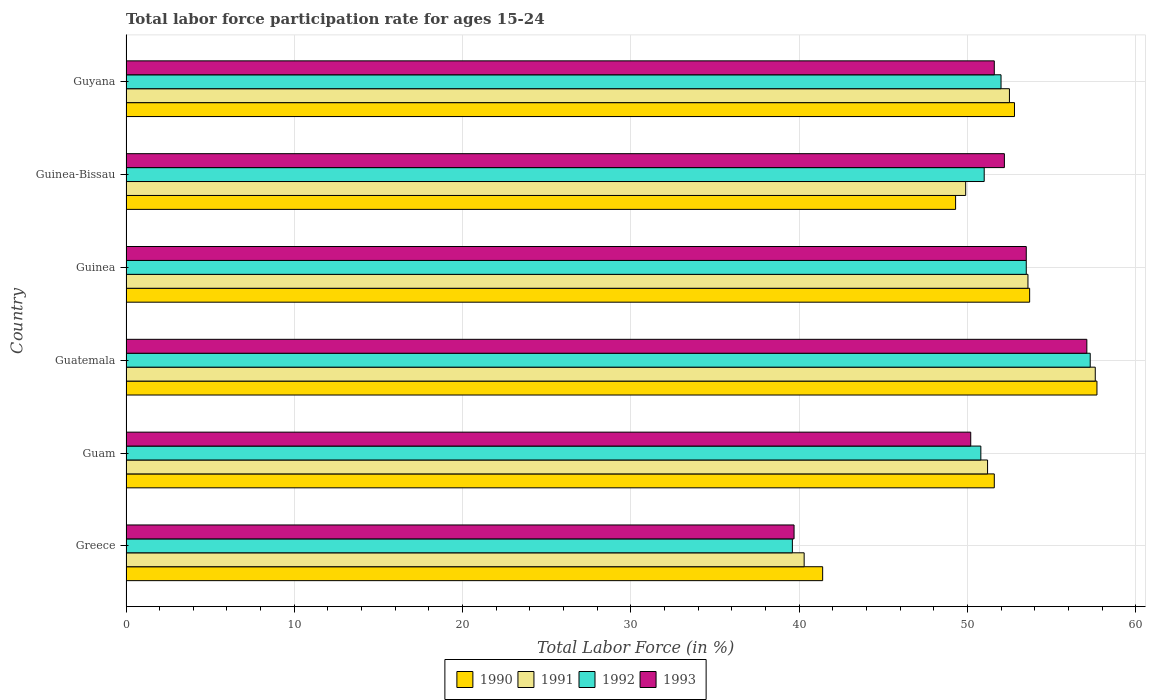Are the number of bars per tick equal to the number of legend labels?
Provide a succinct answer. Yes. What is the label of the 5th group of bars from the top?
Provide a short and direct response. Guam. In how many cases, is the number of bars for a given country not equal to the number of legend labels?
Give a very brief answer. 0. What is the labor force participation rate in 1990 in Guam?
Give a very brief answer. 51.6. Across all countries, what is the maximum labor force participation rate in 1993?
Provide a succinct answer. 57.1. Across all countries, what is the minimum labor force participation rate in 1993?
Give a very brief answer. 39.7. In which country was the labor force participation rate in 1991 maximum?
Provide a short and direct response. Guatemala. What is the total labor force participation rate in 1991 in the graph?
Offer a very short reply. 305.1. What is the difference between the labor force participation rate in 1993 in Guinea-Bissau and that in Guyana?
Provide a succinct answer. 0.6. What is the average labor force participation rate in 1993 per country?
Keep it short and to the point. 50.72. What is the difference between the labor force participation rate in 1993 and labor force participation rate in 1991 in Guatemala?
Ensure brevity in your answer.  -0.5. What is the ratio of the labor force participation rate in 1992 in Guinea to that in Guinea-Bissau?
Your answer should be compact. 1.05. Is the labor force participation rate in 1992 in Guatemala less than that in Guinea-Bissau?
Offer a terse response. No. What is the difference between the highest and the second highest labor force participation rate in 1990?
Keep it short and to the point. 4. What is the difference between the highest and the lowest labor force participation rate in 1992?
Provide a short and direct response. 17.7. Is the sum of the labor force participation rate in 1992 in Guam and Guyana greater than the maximum labor force participation rate in 1991 across all countries?
Give a very brief answer. Yes. What does the 1st bar from the top in Guyana represents?
Give a very brief answer. 1993. Is it the case that in every country, the sum of the labor force participation rate in 1991 and labor force participation rate in 1990 is greater than the labor force participation rate in 1992?
Keep it short and to the point. Yes. How many bars are there?
Keep it short and to the point. 24. How many countries are there in the graph?
Give a very brief answer. 6. What is the difference between two consecutive major ticks on the X-axis?
Ensure brevity in your answer.  10. Are the values on the major ticks of X-axis written in scientific E-notation?
Keep it short and to the point. No. Does the graph contain grids?
Provide a succinct answer. Yes. Where does the legend appear in the graph?
Give a very brief answer. Bottom center. What is the title of the graph?
Give a very brief answer. Total labor force participation rate for ages 15-24. Does "1966" appear as one of the legend labels in the graph?
Your answer should be very brief. No. What is the Total Labor Force (in %) in 1990 in Greece?
Give a very brief answer. 41.4. What is the Total Labor Force (in %) of 1991 in Greece?
Your answer should be compact. 40.3. What is the Total Labor Force (in %) in 1992 in Greece?
Your response must be concise. 39.6. What is the Total Labor Force (in %) in 1993 in Greece?
Your answer should be compact. 39.7. What is the Total Labor Force (in %) of 1990 in Guam?
Keep it short and to the point. 51.6. What is the Total Labor Force (in %) of 1991 in Guam?
Provide a succinct answer. 51.2. What is the Total Labor Force (in %) of 1992 in Guam?
Your answer should be compact. 50.8. What is the Total Labor Force (in %) in 1993 in Guam?
Ensure brevity in your answer.  50.2. What is the Total Labor Force (in %) of 1990 in Guatemala?
Ensure brevity in your answer.  57.7. What is the Total Labor Force (in %) in 1991 in Guatemala?
Make the answer very short. 57.6. What is the Total Labor Force (in %) of 1992 in Guatemala?
Make the answer very short. 57.3. What is the Total Labor Force (in %) in 1993 in Guatemala?
Offer a terse response. 57.1. What is the Total Labor Force (in %) of 1990 in Guinea?
Provide a succinct answer. 53.7. What is the Total Labor Force (in %) of 1991 in Guinea?
Offer a terse response. 53.6. What is the Total Labor Force (in %) of 1992 in Guinea?
Provide a succinct answer. 53.5. What is the Total Labor Force (in %) in 1993 in Guinea?
Provide a succinct answer. 53.5. What is the Total Labor Force (in %) in 1990 in Guinea-Bissau?
Your answer should be compact. 49.3. What is the Total Labor Force (in %) in 1991 in Guinea-Bissau?
Your answer should be compact. 49.9. What is the Total Labor Force (in %) in 1992 in Guinea-Bissau?
Your answer should be compact. 51. What is the Total Labor Force (in %) in 1993 in Guinea-Bissau?
Your answer should be very brief. 52.2. What is the Total Labor Force (in %) of 1990 in Guyana?
Make the answer very short. 52.8. What is the Total Labor Force (in %) in 1991 in Guyana?
Your answer should be very brief. 52.5. What is the Total Labor Force (in %) of 1992 in Guyana?
Offer a very short reply. 52. What is the Total Labor Force (in %) in 1993 in Guyana?
Give a very brief answer. 51.6. Across all countries, what is the maximum Total Labor Force (in %) in 1990?
Give a very brief answer. 57.7. Across all countries, what is the maximum Total Labor Force (in %) of 1991?
Offer a very short reply. 57.6. Across all countries, what is the maximum Total Labor Force (in %) in 1992?
Give a very brief answer. 57.3. Across all countries, what is the maximum Total Labor Force (in %) in 1993?
Provide a succinct answer. 57.1. Across all countries, what is the minimum Total Labor Force (in %) in 1990?
Ensure brevity in your answer.  41.4. Across all countries, what is the minimum Total Labor Force (in %) of 1991?
Offer a very short reply. 40.3. Across all countries, what is the minimum Total Labor Force (in %) of 1992?
Provide a short and direct response. 39.6. Across all countries, what is the minimum Total Labor Force (in %) in 1993?
Your response must be concise. 39.7. What is the total Total Labor Force (in %) of 1990 in the graph?
Give a very brief answer. 306.5. What is the total Total Labor Force (in %) in 1991 in the graph?
Your response must be concise. 305.1. What is the total Total Labor Force (in %) of 1992 in the graph?
Your answer should be compact. 304.2. What is the total Total Labor Force (in %) in 1993 in the graph?
Your response must be concise. 304.3. What is the difference between the Total Labor Force (in %) in 1991 in Greece and that in Guam?
Make the answer very short. -10.9. What is the difference between the Total Labor Force (in %) in 1992 in Greece and that in Guam?
Your response must be concise. -11.2. What is the difference between the Total Labor Force (in %) of 1990 in Greece and that in Guatemala?
Make the answer very short. -16.3. What is the difference between the Total Labor Force (in %) of 1991 in Greece and that in Guatemala?
Offer a very short reply. -17.3. What is the difference between the Total Labor Force (in %) of 1992 in Greece and that in Guatemala?
Your answer should be very brief. -17.7. What is the difference between the Total Labor Force (in %) in 1993 in Greece and that in Guatemala?
Your answer should be compact. -17.4. What is the difference between the Total Labor Force (in %) in 1990 in Greece and that in Guinea?
Your answer should be compact. -12.3. What is the difference between the Total Labor Force (in %) in 1991 in Greece and that in Guinea?
Keep it short and to the point. -13.3. What is the difference between the Total Labor Force (in %) in 1992 in Greece and that in Guinea?
Offer a terse response. -13.9. What is the difference between the Total Labor Force (in %) in 1991 in Greece and that in Guinea-Bissau?
Your answer should be very brief. -9.6. What is the difference between the Total Labor Force (in %) in 1992 in Greece and that in Guinea-Bissau?
Offer a very short reply. -11.4. What is the difference between the Total Labor Force (in %) in 1993 in Greece and that in Guinea-Bissau?
Make the answer very short. -12.5. What is the difference between the Total Labor Force (in %) in 1992 in Guam and that in Guatemala?
Provide a succinct answer. -6.5. What is the difference between the Total Labor Force (in %) of 1993 in Guam and that in Guatemala?
Your answer should be compact. -6.9. What is the difference between the Total Labor Force (in %) of 1990 in Guam and that in Guinea?
Your answer should be compact. -2.1. What is the difference between the Total Labor Force (in %) in 1991 in Guam and that in Guinea?
Your answer should be very brief. -2.4. What is the difference between the Total Labor Force (in %) of 1990 in Guam and that in Guinea-Bissau?
Your response must be concise. 2.3. What is the difference between the Total Labor Force (in %) in 1992 in Guam and that in Guinea-Bissau?
Offer a terse response. -0.2. What is the difference between the Total Labor Force (in %) in 1991 in Guatemala and that in Guinea?
Give a very brief answer. 4. What is the difference between the Total Labor Force (in %) in 1993 in Guatemala and that in Guinea?
Keep it short and to the point. 3.6. What is the difference between the Total Labor Force (in %) of 1990 in Guatemala and that in Guinea-Bissau?
Your answer should be very brief. 8.4. What is the difference between the Total Labor Force (in %) of 1993 in Guatemala and that in Guinea-Bissau?
Ensure brevity in your answer.  4.9. What is the difference between the Total Labor Force (in %) of 1990 in Guatemala and that in Guyana?
Provide a succinct answer. 4.9. What is the difference between the Total Labor Force (in %) of 1992 in Guatemala and that in Guyana?
Offer a very short reply. 5.3. What is the difference between the Total Labor Force (in %) in 1993 in Guatemala and that in Guyana?
Keep it short and to the point. 5.5. What is the difference between the Total Labor Force (in %) of 1990 in Guinea and that in Guinea-Bissau?
Your response must be concise. 4.4. What is the difference between the Total Labor Force (in %) of 1991 in Guinea and that in Guyana?
Ensure brevity in your answer.  1.1. What is the difference between the Total Labor Force (in %) in 1990 in Guinea-Bissau and that in Guyana?
Keep it short and to the point. -3.5. What is the difference between the Total Labor Force (in %) in 1990 in Greece and the Total Labor Force (in %) in 1991 in Guam?
Provide a short and direct response. -9.8. What is the difference between the Total Labor Force (in %) in 1990 in Greece and the Total Labor Force (in %) in 1992 in Guam?
Your answer should be compact. -9.4. What is the difference between the Total Labor Force (in %) in 1990 in Greece and the Total Labor Force (in %) in 1993 in Guam?
Your answer should be very brief. -8.8. What is the difference between the Total Labor Force (in %) of 1991 in Greece and the Total Labor Force (in %) of 1993 in Guam?
Your answer should be very brief. -9.9. What is the difference between the Total Labor Force (in %) in 1990 in Greece and the Total Labor Force (in %) in 1991 in Guatemala?
Ensure brevity in your answer.  -16.2. What is the difference between the Total Labor Force (in %) of 1990 in Greece and the Total Labor Force (in %) of 1992 in Guatemala?
Keep it short and to the point. -15.9. What is the difference between the Total Labor Force (in %) in 1990 in Greece and the Total Labor Force (in %) in 1993 in Guatemala?
Offer a very short reply. -15.7. What is the difference between the Total Labor Force (in %) in 1991 in Greece and the Total Labor Force (in %) in 1992 in Guatemala?
Keep it short and to the point. -17. What is the difference between the Total Labor Force (in %) of 1991 in Greece and the Total Labor Force (in %) of 1993 in Guatemala?
Your answer should be compact. -16.8. What is the difference between the Total Labor Force (in %) in 1992 in Greece and the Total Labor Force (in %) in 1993 in Guatemala?
Provide a succinct answer. -17.5. What is the difference between the Total Labor Force (in %) in 1990 in Greece and the Total Labor Force (in %) in 1991 in Guinea?
Provide a succinct answer. -12.2. What is the difference between the Total Labor Force (in %) of 1991 in Greece and the Total Labor Force (in %) of 1993 in Guinea?
Your answer should be very brief. -13.2. What is the difference between the Total Labor Force (in %) in 1991 in Greece and the Total Labor Force (in %) in 1992 in Guinea-Bissau?
Your response must be concise. -10.7. What is the difference between the Total Labor Force (in %) in 1990 in Greece and the Total Labor Force (in %) in 1991 in Guyana?
Provide a succinct answer. -11.1. What is the difference between the Total Labor Force (in %) in 1990 in Greece and the Total Labor Force (in %) in 1993 in Guyana?
Make the answer very short. -10.2. What is the difference between the Total Labor Force (in %) of 1991 in Greece and the Total Labor Force (in %) of 1992 in Guyana?
Ensure brevity in your answer.  -11.7. What is the difference between the Total Labor Force (in %) of 1992 in Greece and the Total Labor Force (in %) of 1993 in Guyana?
Your answer should be compact. -12. What is the difference between the Total Labor Force (in %) of 1990 in Guam and the Total Labor Force (in %) of 1991 in Guatemala?
Provide a short and direct response. -6. What is the difference between the Total Labor Force (in %) in 1990 in Guam and the Total Labor Force (in %) in 1992 in Guatemala?
Provide a succinct answer. -5.7. What is the difference between the Total Labor Force (in %) of 1990 in Guam and the Total Labor Force (in %) of 1993 in Guatemala?
Keep it short and to the point. -5.5. What is the difference between the Total Labor Force (in %) in 1990 in Guam and the Total Labor Force (in %) in 1991 in Guinea?
Ensure brevity in your answer.  -2. What is the difference between the Total Labor Force (in %) of 1990 in Guam and the Total Labor Force (in %) of 1993 in Guinea?
Your response must be concise. -1.9. What is the difference between the Total Labor Force (in %) in 1991 in Guam and the Total Labor Force (in %) in 1992 in Guinea?
Offer a very short reply. -2.3. What is the difference between the Total Labor Force (in %) in 1991 in Guam and the Total Labor Force (in %) in 1993 in Guinea?
Provide a short and direct response. -2.3. What is the difference between the Total Labor Force (in %) in 1990 in Guam and the Total Labor Force (in %) in 1991 in Guinea-Bissau?
Keep it short and to the point. 1.7. What is the difference between the Total Labor Force (in %) of 1990 in Guam and the Total Labor Force (in %) of 1992 in Guinea-Bissau?
Make the answer very short. 0.6. What is the difference between the Total Labor Force (in %) in 1991 in Guam and the Total Labor Force (in %) in 1992 in Guinea-Bissau?
Provide a succinct answer. 0.2. What is the difference between the Total Labor Force (in %) of 1991 in Guam and the Total Labor Force (in %) of 1993 in Guinea-Bissau?
Your answer should be very brief. -1. What is the difference between the Total Labor Force (in %) in 1990 in Guam and the Total Labor Force (in %) in 1992 in Guyana?
Give a very brief answer. -0.4. What is the difference between the Total Labor Force (in %) of 1991 in Guam and the Total Labor Force (in %) of 1993 in Guyana?
Provide a succinct answer. -0.4. What is the difference between the Total Labor Force (in %) in 1991 in Guatemala and the Total Labor Force (in %) in 1993 in Guinea?
Your answer should be very brief. 4.1. What is the difference between the Total Labor Force (in %) of 1990 in Guatemala and the Total Labor Force (in %) of 1991 in Guinea-Bissau?
Ensure brevity in your answer.  7.8. What is the difference between the Total Labor Force (in %) in 1990 in Guatemala and the Total Labor Force (in %) in 1992 in Guinea-Bissau?
Provide a succinct answer. 6.7. What is the difference between the Total Labor Force (in %) of 1991 in Guatemala and the Total Labor Force (in %) of 1992 in Guinea-Bissau?
Offer a terse response. 6.6. What is the difference between the Total Labor Force (in %) in 1990 in Guatemala and the Total Labor Force (in %) in 1992 in Guyana?
Offer a very short reply. 5.7. What is the difference between the Total Labor Force (in %) in 1991 in Guinea and the Total Labor Force (in %) in 1992 in Guinea-Bissau?
Keep it short and to the point. 2.6. What is the difference between the Total Labor Force (in %) of 1992 in Guinea and the Total Labor Force (in %) of 1993 in Guinea-Bissau?
Keep it short and to the point. 1.3. What is the difference between the Total Labor Force (in %) in 1990 in Guinea and the Total Labor Force (in %) in 1993 in Guyana?
Your answer should be very brief. 2.1. What is the difference between the Total Labor Force (in %) in 1991 in Guinea and the Total Labor Force (in %) in 1992 in Guyana?
Offer a very short reply. 1.6. What is the difference between the Total Labor Force (in %) of 1991 in Guinea-Bissau and the Total Labor Force (in %) of 1993 in Guyana?
Your answer should be very brief. -1.7. What is the average Total Labor Force (in %) of 1990 per country?
Your response must be concise. 51.08. What is the average Total Labor Force (in %) of 1991 per country?
Ensure brevity in your answer.  50.85. What is the average Total Labor Force (in %) of 1992 per country?
Provide a succinct answer. 50.7. What is the average Total Labor Force (in %) of 1993 per country?
Provide a succinct answer. 50.72. What is the difference between the Total Labor Force (in %) in 1990 and Total Labor Force (in %) in 1991 in Greece?
Offer a very short reply. 1.1. What is the difference between the Total Labor Force (in %) of 1990 and Total Labor Force (in %) of 1992 in Greece?
Give a very brief answer. 1.8. What is the difference between the Total Labor Force (in %) of 1991 and Total Labor Force (in %) of 1993 in Greece?
Provide a short and direct response. 0.6. What is the difference between the Total Labor Force (in %) of 1992 and Total Labor Force (in %) of 1993 in Greece?
Give a very brief answer. -0.1. What is the difference between the Total Labor Force (in %) in 1990 and Total Labor Force (in %) in 1991 in Guam?
Give a very brief answer. 0.4. What is the difference between the Total Labor Force (in %) of 1990 and Total Labor Force (in %) of 1992 in Guam?
Offer a very short reply. 0.8. What is the difference between the Total Labor Force (in %) of 1990 and Total Labor Force (in %) of 1993 in Guam?
Keep it short and to the point. 1.4. What is the difference between the Total Labor Force (in %) of 1991 and Total Labor Force (in %) of 1993 in Guam?
Provide a succinct answer. 1. What is the difference between the Total Labor Force (in %) of 1990 and Total Labor Force (in %) of 1991 in Guatemala?
Make the answer very short. 0.1. What is the difference between the Total Labor Force (in %) in 1990 and Total Labor Force (in %) in 1992 in Guatemala?
Make the answer very short. 0.4. What is the difference between the Total Labor Force (in %) of 1991 and Total Labor Force (in %) of 1992 in Guatemala?
Keep it short and to the point. 0.3. What is the difference between the Total Labor Force (in %) of 1991 and Total Labor Force (in %) of 1993 in Guatemala?
Provide a succinct answer. 0.5. What is the difference between the Total Labor Force (in %) in 1990 and Total Labor Force (in %) in 1991 in Guinea?
Your answer should be compact. 0.1. What is the difference between the Total Labor Force (in %) in 1990 and Total Labor Force (in %) in 1993 in Guinea?
Offer a very short reply. 0.2. What is the difference between the Total Labor Force (in %) in 1991 and Total Labor Force (in %) in 1992 in Guinea?
Keep it short and to the point. 0.1. What is the difference between the Total Labor Force (in %) in 1992 and Total Labor Force (in %) in 1993 in Guinea?
Your answer should be compact. 0. What is the difference between the Total Labor Force (in %) in 1990 and Total Labor Force (in %) in 1992 in Guinea-Bissau?
Your answer should be very brief. -1.7. What is the difference between the Total Labor Force (in %) in 1991 and Total Labor Force (in %) in 1992 in Guinea-Bissau?
Offer a terse response. -1.1. What is the difference between the Total Labor Force (in %) in 1990 and Total Labor Force (in %) in 1992 in Guyana?
Your answer should be compact. 0.8. What is the ratio of the Total Labor Force (in %) in 1990 in Greece to that in Guam?
Keep it short and to the point. 0.8. What is the ratio of the Total Labor Force (in %) of 1991 in Greece to that in Guam?
Provide a succinct answer. 0.79. What is the ratio of the Total Labor Force (in %) in 1992 in Greece to that in Guam?
Give a very brief answer. 0.78. What is the ratio of the Total Labor Force (in %) in 1993 in Greece to that in Guam?
Ensure brevity in your answer.  0.79. What is the ratio of the Total Labor Force (in %) in 1990 in Greece to that in Guatemala?
Offer a very short reply. 0.72. What is the ratio of the Total Labor Force (in %) in 1991 in Greece to that in Guatemala?
Keep it short and to the point. 0.7. What is the ratio of the Total Labor Force (in %) in 1992 in Greece to that in Guatemala?
Offer a very short reply. 0.69. What is the ratio of the Total Labor Force (in %) in 1993 in Greece to that in Guatemala?
Make the answer very short. 0.7. What is the ratio of the Total Labor Force (in %) in 1990 in Greece to that in Guinea?
Give a very brief answer. 0.77. What is the ratio of the Total Labor Force (in %) of 1991 in Greece to that in Guinea?
Give a very brief answer. 0.75. What is the ratio of the Total Labor Force (in %) of 1992 in Greece to that in Guinea?
Offer a very short reply. 0.74. What is the ratio of the Total Labor Force (in %) in 1993 in Greece to that in Guinea?
Make the answer very short. 0.74. What is the ratio of the Total Labor Force (in %) of 1990 in Greece to that in Guinea-Bissau?
Keep it short and to the point. 0.84. What is the ratio of the Total Labor Force (in %) in 1991 in Greece to that in Guinea-Bissau?
Make the answer very short. 0.81. What is the ratio of the Total Labor Force (in %) in 1992 in Greece to that in Guinea-Bissau?
Ensure brevity in your answer.  0.78. What is the ratio of the Total Labor Force (in %) in 1993 in Greece to that in Guinea-Bissau?
Give a very brief answer. 0.76. What is the ratio of the Total Labor Force (in %) in 1990 in Greece to that in Guyana?
Make the answer very short. 0.78. What is the ratio of the Total Labor Force (in %) in 1991 in Greece to that in Guyana?
Your answer should be very brief. 0.77. What is the ratio of the Total Labor Force (in %) of 1992 in Greece to that in Guyana?
Provide a succinct answer. 0.76. What is the ratio of the Total Labor Force (in %) of 1993 in Greece to that in Guyana?
Provide a short and direct response. 0.77. What is the ratio of the Total Labor Force (in %) in 1990 in Guam to that in Guatemala?
Ensure brevity in your answer.  0.89. What is the ratio of the Total Labor Force (in %) in 1992 in Guam to that in Guatemala?
Offer a very short reply. 0.89. What is the ratio of the Total Labor Force (in %) in 1993 in Guam to that in Guatemala?
Ensure brevity in your answer.  0.88. What is the ratio of the Total Labor Force (in %) of 1990 in Guam to that in Guinea?
Provide a succinct answer. 0.96. What is the ratio of the Total Labor Force (in %) of 1991 in Guam to that in Guinea?
Your answer should be very brief. 0.96. What is the ratio of the Total Labor Force (in %) in 1992 in Guam to that in Guinea?
Provide a succinct answer. 0.95. What is the ratio of the Total Labor Force (in %) of 1993 in Guam to that in Guinea?
Offer a very short reply. 0.94. What is the ratio of the Total Labor Force (in %) of 1990 in Guam to that in Guinea-Bissau?
Offer a very short reply. 1.05. What is the ratio of the Total Labor Force (in %) in 1991 in Guam to that in Guinea-Bissau?
Your response must be concise. 1.03. What is the ratio of the Total Labor Force (in %) in 1993 in Guam to that in Guinea-Bissau?
Your answer should be very brief. 0.96. What is the ratio of the Total Labor Force (in %) of 1990 in Guam to that in Guyana?
Provide a short and direct response. 0.98. What is the ratio of the Total Labor Force (in %) of 1991 in Guam to that in Guyana?
Offer a very short reply. 0.98. What is the ratio of the Total Labor Force (in %) in 1992 in Guam to that in Guyana?
Provide a short and direct response. 0.98. What is the ratio of the Total Labor Force (in %) of 1993 in Guam to that in Guyana?
Make the answer very short. 0.97. What is the ratio of the Total Labor Force (in %) of 1990 in Guatemala to that in Guinea?
Your response must be concise. 1.07. What is the ratio of the Total Labor Force (in %) in 1991 in Guatemala to that in Guinea?
Offer a terse response. 1.07. What is the ratio of the Total Labor Force (in %) in 1992 in Guatemala to that in Guinea?
Your response must be concise. 1.07. What is the ratio of the Total Labor Force (in %) of 1993 in Guatemala to that in Guinea?
Provide a succinct answer. 1.07. What is the ratio of the Total Labor Force (in %) of 1990 in Guatemala to that in Guinea-Bissau?
Keep it short and to the point. 1.17. What is the ratio of the Total Labor Force (in %) in 1991 in Guatemala to that in Guinea-Bissau?
Your answer should be very brief. 1.15. What is the ratio of the Total Labor Force (in %) of 1992 in Guatemala to that in Guinea-Bissau?
Offer a very short reply. 1.12. What is the ratio of the Total Labor Force (in %) in 1993 in Guatemala to that in Guinea-Bissau?
Keep it short and to the point. 1.09. What is the ratio of the Total Labor Force (in %) in 1990 in Guatemala to that in Guyana?
Provide a short and direct response. 1.09. What is the ratio of the Total Labor Force (in %) of 1991 in Guatemala to that in Guyana?
Ensure brevity in your answer.  1.1. What is the ratio of the Total Labor Force (in %) of 1992 in Guatemala to that in Guyana?
Provide a succinct answer. 1.1. What is the ratio of the Total Labor Force (in %) of 1993 in Guatemala to that in Guyana?
Your answer should be compact. 1.11. What is the ratio of the Total Labor Force (in %) in 1990 in Guinea to that in Guinea-Bissau?
Your response must be concise. 1.09. What is the ratio of the Total Labor Force (in %) of 1991 in Guinea to that in Guinea-Bissau?
Your answer should be very brief. 1.07. What is the ratio of the Total Labor Force (in %) of 1992 in Guinea to that in Guinea-Bissau?
Ensure brevity in your answer.  1.05. What is the ratio of the Total Labor Force (in %) of 1993 in Guinea to that in Guinea-Bissau?
Provide a short and direct response. 1.02. What is the ratio of the Total Labor Force (in %) in 1990 in Guinea to that in Guyana?
Offer a terse response. 1.02. What is the ratio of the Total Labor Force (in %) in 1992 in Guinea to that in Guyana?
Offer a very short reply. 1.03. What is the ratio of the Total Labor Force (in %) in 1993 in Guinea to that in Guyana?
Your response must be concise. 1.04. What is the ratio of the Total Labor Force (in %) of 1990 in Guinea-Bissau to that in Guyana?
Give a very brief answer. 0.93. What is the ratio of the Total Labor Force (in %) in 1991 in Guinea-Bissau to that in Guyana?
Your answer should be compact. 0.95. What is the ratio of the Total Labor Force (in %) in 1992 in Guinea-Bissau to that in Guyana?
Keep it short and to the point. 0.98. What is the ratio of the Total Labor Force (in %) in 1993 in Guinea-Bissau to that in Guyana?
Offer a very short reply. 1.01. What is the difference between the highest and the second highest Total Labor Force (in %) in 1990?
Your response must be concise. 4. What is the difference between the highest and the second highest Total Labor Force (in %) of 1992?
Your response must be concise. 3.8. What is the difference between the highest and the lowest Total Labor Force (in %) in 1990?
Offer a terse response. 16.3. 